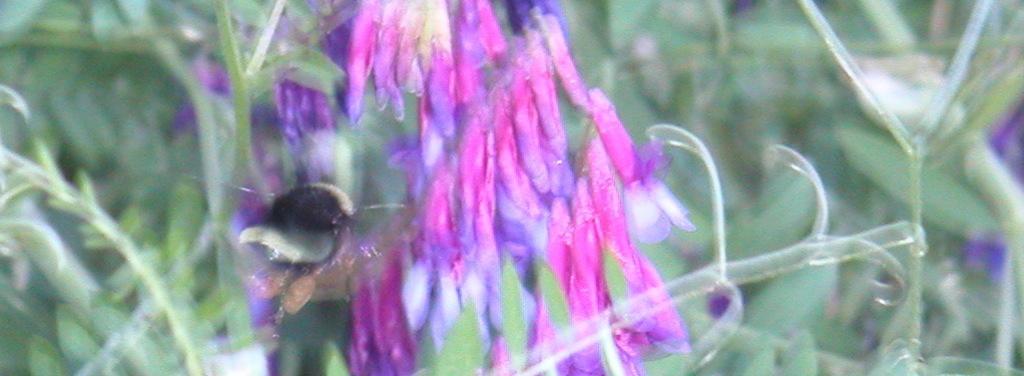Could you give a brief overview of what you see in this image? This picture is blur,we can see flowers,background it is green. 